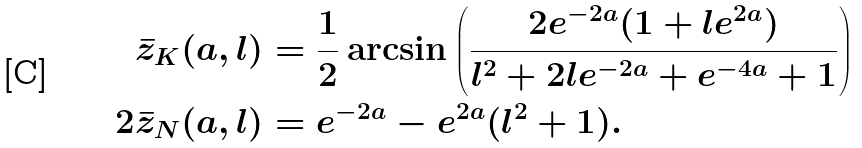<formula> <loc_0><loc_0><loc_500><loc_500>\bar { z } _ { K } ( a , l ) & = \frac { 1 } { 2 } \arcsin \left ( \frac { 2 e ^ { - 2 a } ( 1 + l e ^ { 2 a } ) } { l ^ { 2 } + 2 l e ^ { - 2 a } + e ^ { - 4 a } + 1 } \right ) \\ 2 \bar { z } _ { N } ( a , l ) & = e ^ { - 2 a } - e ^ { 2 a } ( l ^ { 2 } + 1 ) .</formula> 